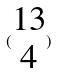Convert formula to latex. <formula><loc_0><loc_0><loc_500><loc_500>( \begin{matrix} 1 3 \\ 4 \end{matrix} )</formula> 